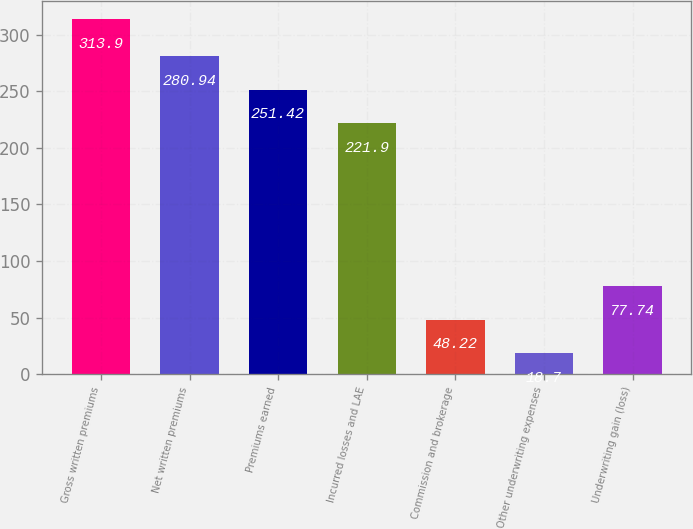<chart> <loc_0><loc_0><loc_500><loc_500><bar_chart><fcel>Gross written premiums<fcel>Net written premiums<fcel>Premiums earned<fcel>Incurred losses and LAE<fcel>Commission and brokerage<fcel>Other underwriting expenses<fcel>Underwriting gain (loss)<nl><fcel>313.9<fcel>280.94<fcel>251.42<fcel>221.9<fcel>48.22<fcel>18.7<fcel>77.74<nl></chart> 